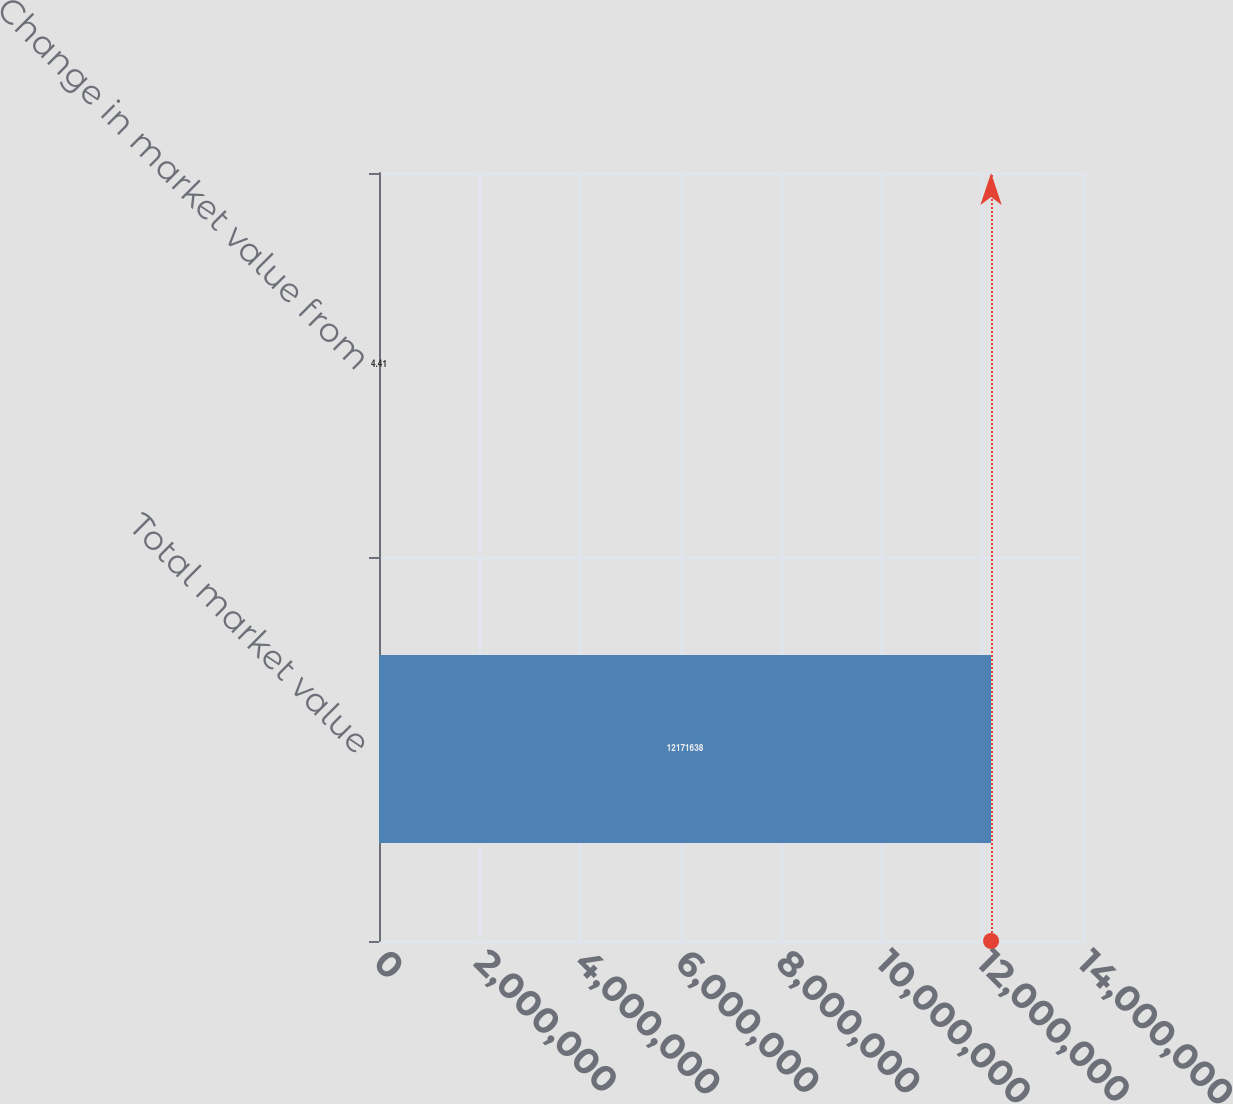Convert chart to OTSL. <chart><loc_0><loc_0><loc_500><loc_500><bar_chart><fcel>Total market value<fcel>Change in market value from<nl><fcel>1.21716e+07<fcel>4.41<nl></chart> 